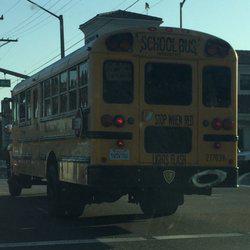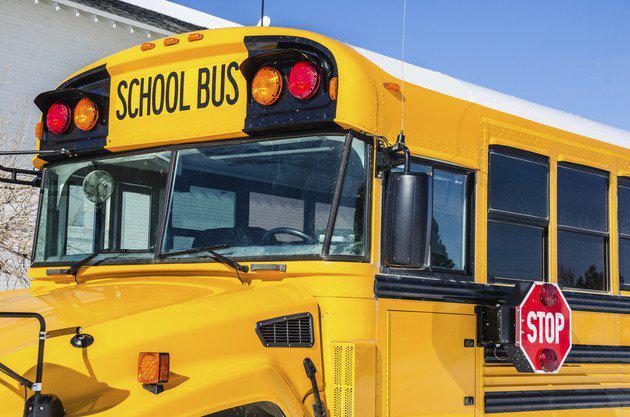The first image is the image on the left, the second image is the image on the right. For the images displayed, is the sentence "One image shows a horizontal view of a long bus with an extra door on the side near the middle of the bus." factually correct? Answer yes or no. No. The first image is the image on the left, the second image is the image on the right. For the images shown, is this caption "One bus' passenger door is open." true? Answer yes or no. No. 